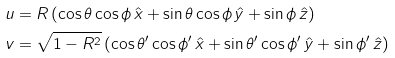Convert formula to latex. <formula><loc_0><loc_0><loc_500><loc_500>u & = R \left ( \cos \theta \cos \phi \, \hat { x } + \sin \theta \cos \phi \, \hat { y } + \sin \phi \, \hat { z } \right ) \\ v & = \sqrt { 1 - R ^ { 2 } } \left ( \cos \theta ^ { \prime } \cos \phi ^ { \prime } \, \hat { x } + \sin \theta ^ { \prime } \cos \phi ^ { \prime } \, \hat { y } + \sin \phi ^ { \prime } \, \hat { z } \right )</formula> 